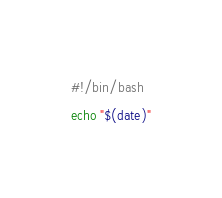<code> <loc_0><loc_0><loc_500><loc_500><_Bash_>#!/bin/bash
echo "$(date)"</code> 